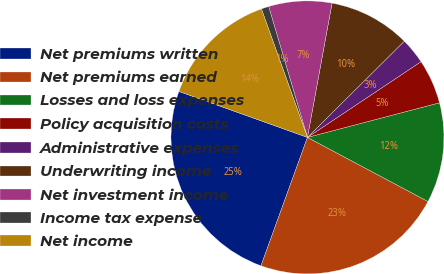<chart> <loc_0><loc_0><loc_500><loc_500><pie_chart><fcel>Net premiums written<fcel>Net premiums earned<fcel>Losses and loss expenses<fcel>Policy acquisition costs<fcel>Administrative expenses<fcel>Underwriting income<fcel>Net investment income<fcel>Income tax expense<fcel>Net income<nl><fcel>24.94%<fcel>22.75%<fcel>11.86%<fcel>5.28%<fcel>3.09%<fcel>9.67%<fcel>7.47%<fcel>0.89%<fcel>14.06%<nl></chart> 